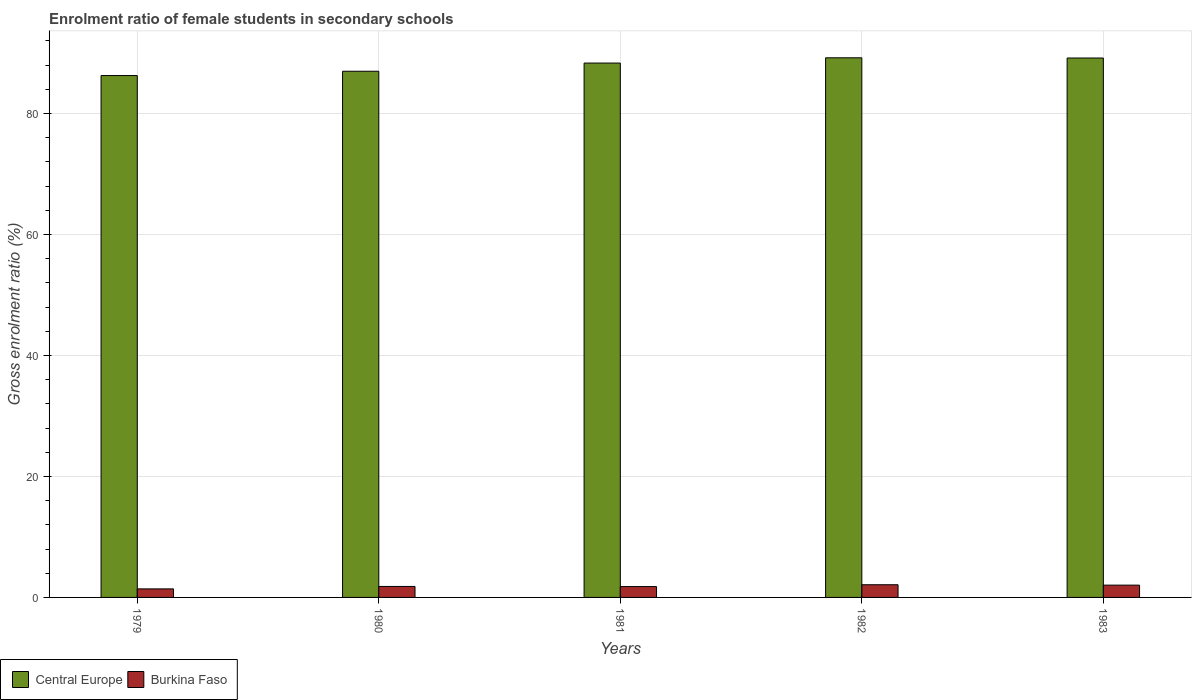How many groups of bars are there?
Offer a terse response. 5. Are the number of bars per tick equal to the number of legend labels?
Your response must be concise. Yes. How many bars are there on the 3rd tick from the left?
Offer a terse response. 2. What is the enrolment ratio of female students in secondary schools in Burkina Faso in 1979?
Your answer should be very brief. 1.41. Across all years, what is the maximum enrolment ratio of female students in secondary schools in Central Europe?
Ensure brevity in your answer.  89.21. Across all years, what is the minimum enrolment ratio of female students in secondary schools in Central Europe?
Keep it short and to the point. 86.27. In which year was the enrolment ratio of female students in secondary schools in Central Europe maximum?
Offer a very short reply. 1982. In which year was the enrolment ratio of female students in secondary schools in Burkina Faso minimum?
Your response must be concise. 1979. What is the total enrolment ratio of female students in secondary schools in Central Europe in the graph?
Provide a succinct answer. 439.99. What is the difference between the enrolment ratio of female students in secondary schools in Central Europe in 1980 and that in 1981?
Provide a short and direct response. -1.35. What is the difference between the enrolment ratio of female students in secondary schools in Burkina Faso in 1983 and the enrolment ratio of female students in secondary schools in Central Europe in 1979?
Offer a very short reply. -84.24. What is the average enrolment ratio of female students in secondary schools in Burkina Faso per year?
Your answer should be compact. 1.83. In the year 1981, what is the difference between the enrolment ratio of female students in secondary schools in Central Europe and enrolment ratio of female students in secondary schools in Burkina Faso?
Your answer should be compact. 86.55. What is the ratio of the enrolment ratio of female students in secondary schools in Burkina Faso in 1982 to that in 1983?
Your response must be concise. 1.03. Is the difference between the enrolment ratio of female students in secondary schools in Central Europe in 1979 and 1982 greater than the difference between the enrolment ratio of female students in secondary schools in Burkina Faso in 1979 and 1982?
Offer a very short reply. No. What is the difference between the highest and the second highest enrolment ratio of female students in secondary schools in Central Europe?
Offer a terse response. 0.03. What is the difference between the highest and the lowest enrolment ratio of female students in secondary schools in Burkina Faso?
Ensure brevity in your answer.  0.69. What does the 2nd bar from the left in 1982 represents?
Keep it short and to the point. Burkina Faso. What does the 1st bar from the right in 1979 represents?
Your answer should be very brief. Burkina Faso. Are all the bars in the graph horizontal?
Offer a very short reply. No. How many years are there in the graph?
Make the answer very short. 5. Where does the legend appear in the graph?
Your answer should be compact. Bottom left. What is the title of the graph?
Your answer should be very brief. Enrolment ratio of female students in secondary schools. What is the label or title of the Y-axis?
Give a very brief answer. Gross enrolment ratio (%). What is the Gross enrolment ratio (%) of Central Europe in 1979?
Ensure brevity in your answer.  86.27. What is the Gross enrolment ratio (%) in Burkina Faso in 1979?
Make the answer very short. 1.41. What is the Gross enrolment ratio (%) in Central Europe in 1980?
Keep it short and to the point. 86.99. What is the Gross enrolment ratio (%) of Burkina Faso in 1980?
Make the answer very short. 1.82. What is the Gross enrolment ratio (%) in Central Europe in 1981?
Your answer should be very brief. 88.34. What is the Gross enrolment ratio (%) in Burkina Faso in 1981?
Offer a terse response. 1.79. What is the Gross enrolment ratio (%) of Central Europe in 1982?
Offer a very short reply. 89.21. What is the Gross enrolment ratio (%) of Burkina Faso in 1982?
Your answer should be compact. 2.1. What is the Gross enrolment ratio (%) in Central Europe in 1983?
Offer a very short reply. 89.17. What is the Gross enrolment ratio (%) in Burkina Faso in 1983?
Ensure brevity in your answer.  2.03. Across all years, what is the maximum Gross enrolment ratio (%) of Central Europe?
Your answer should be very brief. 89.21. Across all years, what is the maximum Gross enrolment ratio (%) of Burkina Faso?
Your answer should be very brief. 2.1. Across all years, what is the minimum Gross enrolment ratio (%) in Central Europe?
Keep it short and to the point. 86.27. Across all years, what is the minimum Gross enrolment ratio (%) in Burkina Faso?
Keep it short and to the point. 1.41. What is the total Gross enrolment ratio (%) of Central Europe in the graph?
Provide a succinct answer. 439.99. What is the total Gross enrolment ratio (%) of Burkina Faso in the graph?
Your answer should be very brief. 9.15. What is the difference between the Gross enrolment ratio (%) of Central Europe in 1979 and that in 1980?
Offer a terse response. -0.71. What is the difference between the Gross enrolment ratio (%) in Burkina Faso in 1979 and that in 1980?
Make the answer very short. -0.4. What is the difference between the Gross enrolment ratio (%) of Central Europe in 1979 and that in 1981?
Ensure brevity in your answer.  -2.07. What is the difference between the Gross enrolment ratio (%) in Burkina Faso in 1979 and that in 1981?
Your answer should be compact. -0.38. What is the difference between the Gross enrolment ratio (%) in Central Europe in 1979 and that in 1982?
Give a very brief answer. -2.94. What is the difference between the Gross enrolment ratio (%) of Burkina Faso in 1979 and that in 1982?
Your answer should be compact. -0.69. What is the difference between the Gross enrolment ratio (%) of Central Europe in 1979 and that in 1983?
Keep it short and to the point. -2.9. What is the difference between the Gross enrolment ratio (%) in Burkina Faso in 1979 and that in 1983?
Keep it short and to the point. -0.62. What is the difference between the Gross enrolment ratio (%) of Central Europe in 1980 and that in 1981?
Make the answer very short. -1.35. What is the difference between the Gross enrolment ratio (%) of Burkina Faso in 1980 and that in 1981?
Keep it short and to the point. 0.02. What is the difference between the Gross enrolment ratio (%) of Central Europe in 1980 and that in 1982?
Provide a short and direct response. -2.22. What is the difference between the Gross enrolment ratio (%) in Burkina Faso in 1980 and that in 1982?
Your answer should be compact. -0.28. What is the difference between the Gross enrolment ratio (%) in Central Europe in 1980 and that in 1983?
Your answer should be compact. -2.19. What is the difference between the Gross enrolment ratio (%) in Burkina Faso in 1980 and that in 1983?
Make the answer very short. -0.22. What is the difference between the Gross enrolment ratio (%) of Central Europe in 1981 and that in 1982?
Your answer should be very brief. -0.87. What is the difference between the Gross enrolment ratio (%) in Burkina Faso in 1981 and that in 1982?
Keep it short and to the point. -0.31. What is the difference between the Gross enrolment ratio (%) of Central Europe in 1981 and that in 1983?
Make the answer very short. -0.83. What is the difference between the Gross enrolment ratio (%) in Burkina Faso in 1981 and that in 1983?
Provide a short and direct response. -0.24. What is the difference between the Gross enrolment ratio (%) of Central Europe in 1982 and that in 1983?
Provide a short and direct response. 0.03. What is the difference between the Gross enrolment ratio (%) in Burkina Faso in 1982 and that in 1983?
Your answer should be compact. 0.06. What is the difference between the Gross enrolment ratio (%) of Central Europe in 1979 and the Gross enrolment ratio (%) of Burkina Faso in 1980?
Your answer should be compact. 84.46. What is the difference between the Gross enrolment ratio (%) of Central Europe in 1979 and the Gross enrolment ratio (%) of Burkina Faso in 1981?
Provide a short and direct response. 84.48. What is the difference between the Gross enrolment ratio (%) of Central Europe in 1979 and the Gross enrolment ratio (%) of Burkina Faso in 1982?
Keep it short and to the point. 84.18. What is the difference between the Gross enrolment ratio (%) in Central Europe in 1979 and the Gross enrolment ratio (%) in Burkina Faso in 1983?
Ensure brevity in your answer.  84.24. What is the difference between the Gross enrolment ratio (%) in Central Europe in 1980 and the Gross enrolment ratio (%) in Burkina Faso in 1981?
Give a very brief answer. 85.2. What is the difference between the Gross enrolment ratio (%) in Central Europe in 1980 and the Gross enrolment ratio (%) in Burkina Faso in 1982?
Your response must be concise. 84.89. What is the difference between the Gross enrolment ratio (%) of Central Europe in 1980 and the Gross enrolment ratio (%) of Burkina Faso in 1983?
Provide a succinct answer. 84.96. What is the difference between the Gross enrolment ratio (%) in Central Europe in 1981 and the Gross enrolment ratio (%) in Burkina Faso in 1982?
Provide a short and direct response. 86.24. What is the difference between the Gross enrolment ratio (%) in Central Europe in 1981 and the Gross enrolment ratio (%) in Burkina Faso in 1983?
Your response must be concise. 86.31. What is the difference between the Gross enrolment ratio (%) in Central Europe in 1982 and the Gross enrolment ratio (%) in Burkina Faso in 1983?
Offer a very short reply. 87.18. What is the average Gross enrolment ratio (%) of Central Europe per year?
Offer a terse response. 88. What is the average Gross enrolment ratio (%) in Burkina Faso per year?
Keep it short and to the point. 1.83. In the year 1979, what is the difference between the Gross enrolment ratio (%) in Central Europe and Gross enrolment ratio (%) in Burkina Faso?
Your answer should be compact. 84.86. In the year 1980, what is the difference between the Gross enrolment ratio (%) of Central Europe and Gross enrolment ratio (%) of Burkina Faso?
Keep it short and to the point. 85.17. In the year 1981, what is the difference between the Gross enrolment ratio (%) in Central Europe and Gross enrolment ratio (%) in Burkina Faso?
Offer a terse response. 86.55. In the year 1982, what is the difference between the Gross enrolment ratio (%) in Central Europe and Gross enrolment ratio (%) in Burkina Faso?
Give a very brief answer. 87.11. In the year 1983, what is the difference between the Gross enrolment ratio (%) of Central Europe and Gross enrolment ratio (%) of Burkina Faso?
Offer a terse response. 87.14. What is the ratio of the Gross enrolment ratio (%) of Central Europe in 1979 to that in 1980?
Offer a terse response. 0.99. What is the ratio of the Gross enrolment ratio (%) of Burkina Faso in 1979 to that in 1980?
Your response must be concise. 0.78. What is the ratio of the Gross enrolment ratio (%) in Central Europe in 1979 to that in 1981?
Give a very brief answer. 0.98. What is the ratio of the Gross enrolment ratio (%) of Burkina Faso in 1979 to that in 1981?
Offer a terse response. 0.79. What is the ratio of the Gross enrolment ratio (%) in Central Europe in 1979 to that in 1982?
Ensure brevity in your answer.  0.97. What is the ratio of the Gross enrolment ratio (%) in Burkina Faso in 1979 to that in 1982?
Make the answer very short. 0.67. What is the ratio of the Gross enrolment ratio (%) of Central Europe in 1979 to that in 1983?
Provide a short and direct response. 0.97. What is the ratio of the Gross enrolment ratio (%) in Burkina Faso in 1979 to that in 1983?
Offer a very short reply. 0.69. What is the ratio of the Gross enrolment ratio (%) in Central Europe in 1980 to that in 1981?
Ensure brevity in your answer.  0.98. What is the ratio of the Gross enrolment ratio (%) of Burkina Faso in 1980 to that in 1981?
Keep it short and to the point. 1.01. What is the ratio of the Gross enrolment ratio (%) in Central Europe in 1980 to that in 1982?
Offer a terse response. 0.98. What is the ratio of the Gross enrolment ratio (%) in Burkina Faso in 1980 to that in 1982?
Make the answer very short. 0.87. What is the ratio of the Gross enrolment ratio (%) of Central Europe in 1980 to that in 1983?
Make the answer very short. 0.98. What is the ratio of the Gross enrolment ratio (%) of Burkina Faso in 1980 to that in 1983?
Make the answer very short. 0.89. What is the ratio of the Gross enrolment ratio (%) in Central Europe in 1981 to that in 1982?
Offer a very short reply. 0.99. What is the ratio of the Gross enrolment ratio (%) in Burkina Faso in 1981 to that in 1982?
Make the answer very short. 0.85. What is the ratio of the Gross enrolment ratio (%) of Burkina Faso in 1981 to that in 1983?
Your answer should be very brief. 0.88. What is the ratio of the Gross enrolment ratio (%) of Central Europe in 1982 to that in 1983?
Ensure brevity in your answer.  1. What is the ratio of the Gross enrolment ratio (%) of Burkina Faso in 1982 to that in 1983?
Your answer should be very brief. 1.03. What is the difference between the highest and the second highest Gross enrolment ratio (%) in Central Europe?
Provide a succinct answer. 0.03. What is the difference between the highest and the second highest Gross enrolment ratio (%) of Burkina Faso?
Provide a short and direct response. 0.06. What is the difference between the highest and the lowest Gross enrolment ratio (%) in Central Europe?
Your response must be concise. 2.94. What is the difference between the highest and the lowest Gross enrolment ratio (%) of Burkina Faso?
Ensure brevity in your answer.  0.69. 